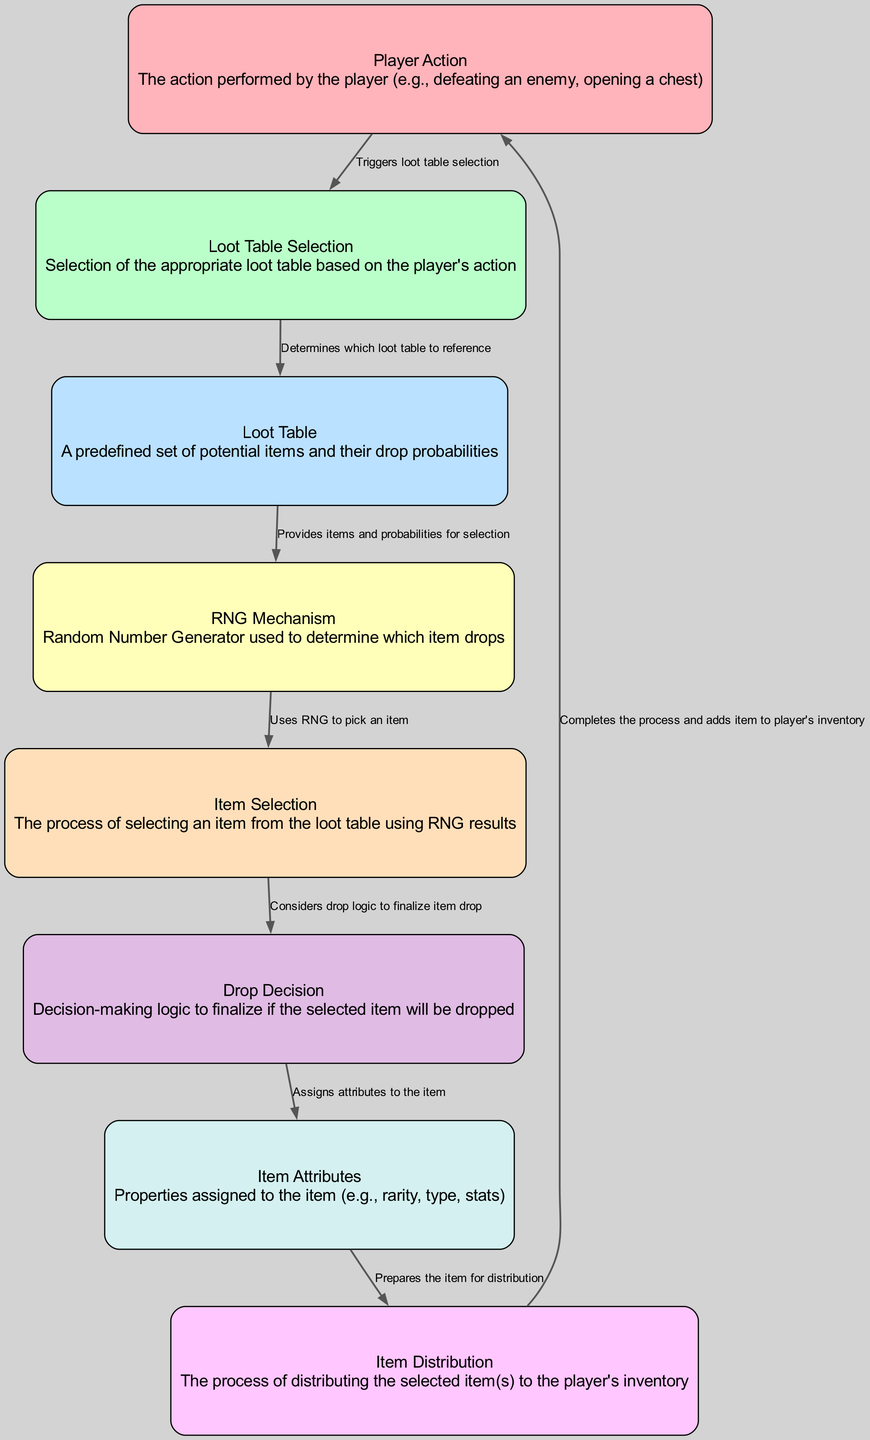What triggers the loot table selection? According to the diagram, the "Player Action" node is directly connected to the "Loot Table Selection" node, indicating that the player's action is what triggers the selection of the loot table.
Answer: Player Action How many nodes are in the diagram? By counting the distinct nodes listed in the "nodes" section of the data, we find that there are 8 nodes in total related to the loot generation system.
Answer: 8 What is assigned to the item during the drop decision? The "Drop Decision" node connects to the "Item Attributes" node, implying that item attributes are assigned as part of the drop decision process.
Answer: Item Attributes Which component uses RNG to pick an item? The "RNG Mechanism" node is specifically labeled to represent the mechanism that utilizes random number generation to select an item from the loot table.
Answer: RNG Mechanism What connects the item attributes to the item's distribution? The "Item Attributes" node feeds into the "Item Distribution" node, which illustrates that item attributes are necessary for preparing the item for distribution to the player's inventory.
Answer: Item Distribution Which node provides items and probabilities for selection? The "Loot Table" node is responsible for providing the items and their drop probabilities to the "RNG Mechanism," making it the source of this information.
Answer: Loot Table How does the loot generation process end? The diagram shows that the process concludes when the "Item Distribution" node connects back to the "Player Action" node, indicating that the items are added back to the player's inventory, completing the process.
Answer: Player Action What decision-making logic is considered after item selection? The "Drop Decision" node is linked to the "Item Selection" node and is responsible for considering the logic that finalizes whether the selected item will indeed be dropped.
Answer: Drop Decision 